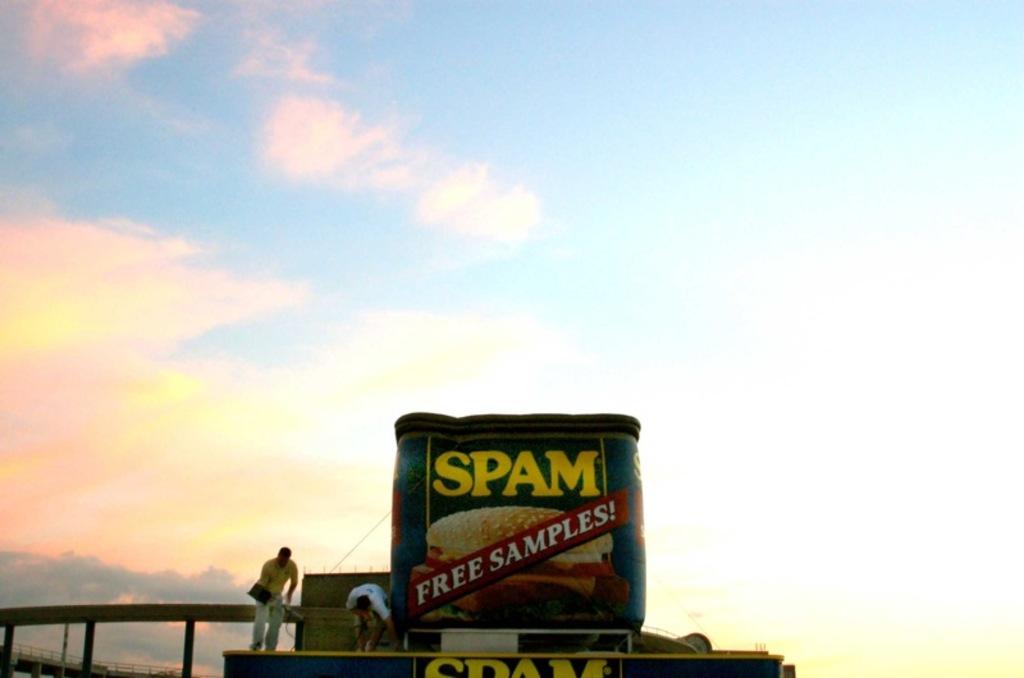What is the name of the food in the image?
Make the answer very short. Spam. What is the cost of the samples of the product?
Ensure brevity in your answer.  Free. 